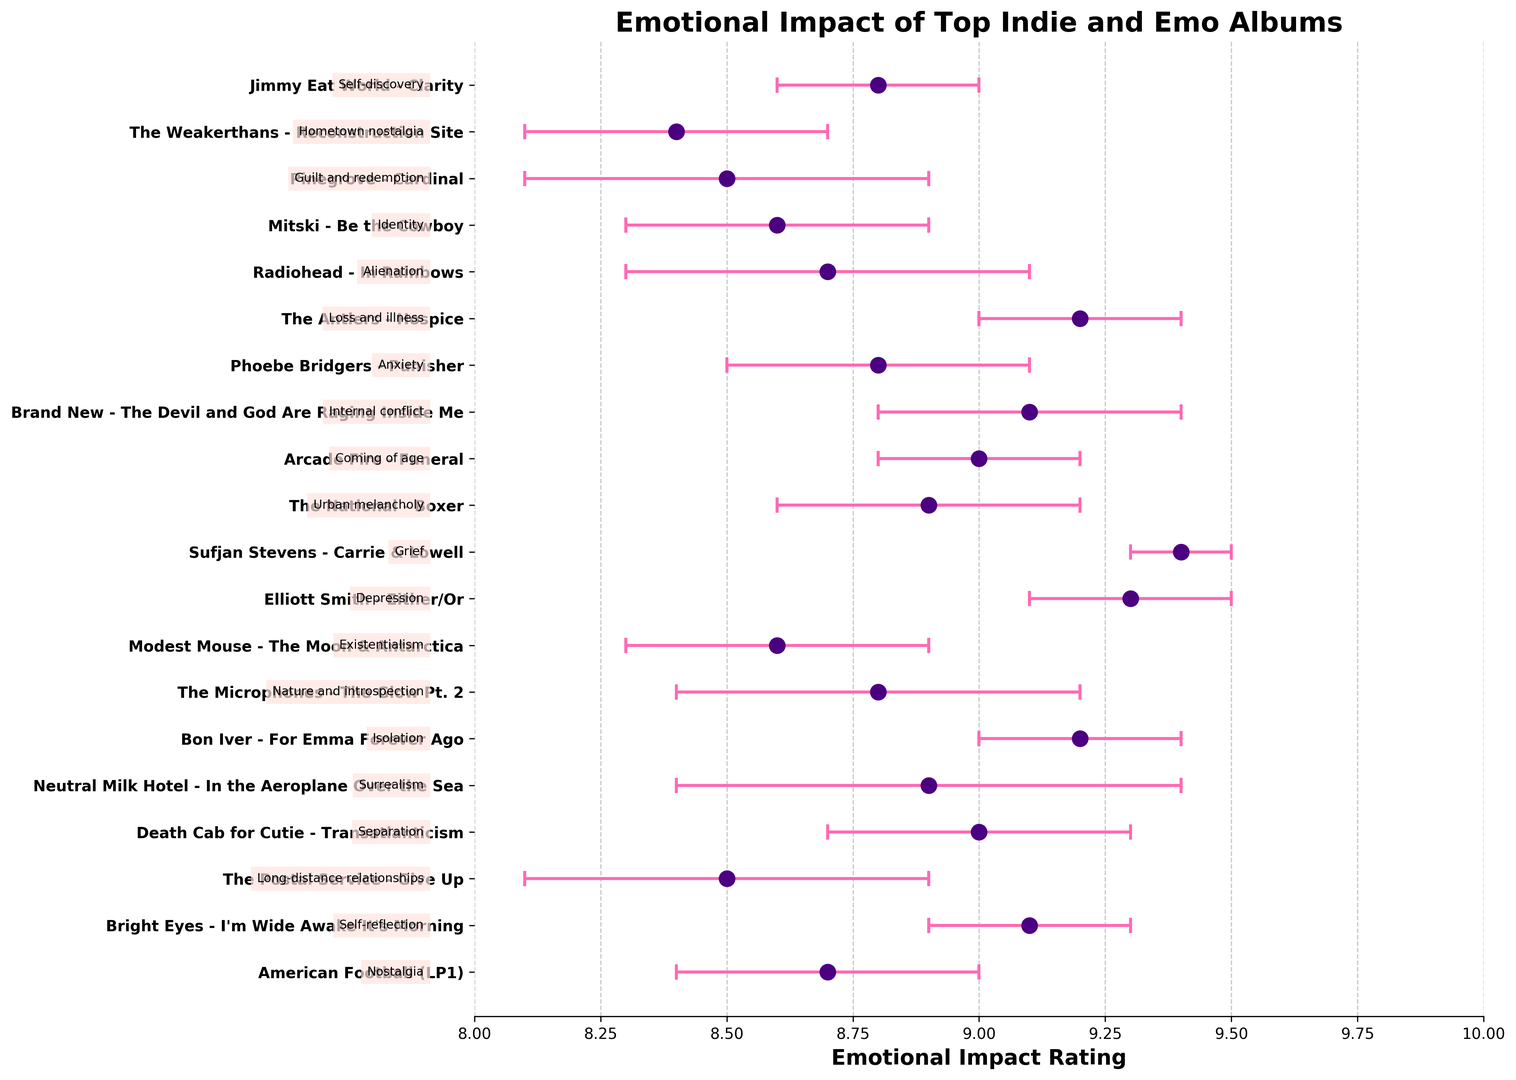What's the range of emotional impact ratings? The minimum rating is 8.4 (The Weakerthans - Reconstruction Site) and the maximum rating is 9.4 (Sufjan Stevens - Carrie & Lowell). The range is calculated as 9.4 - 8.4 = 1.
Answer: 1 Which album has the highest emotional impact rating? Sufjan Stevens - Carrie & Lowell has the highest emotional impact rating of 9.4.
Answer: Sufjan Stevens - Carrie & Lowell Which albums have an emotional impact rating of 8.7? The albums with an emotional impact rating of 8.7 are American Football (LP1) by American Football and In Rainbows by Radiohead, as indicated by the data points aligned at the 8.7 rating mark.
Answer: American Football (LP1) and In Rainbows How many albums have an emotional impact rating of 9.0 or higher? There are 8 albums with an emotional impact rating of 9.0 or higher: Bright Eyes - I'm Wide Awake It's Morning, Death Cab for Cutie - Transatlanticism, Neutral Milk Hotel - In the Aeroplane Over the Sea, Elliott Smith - Either/Or, Sufjan Stevens - Carrie & Lowell, Arcade Fire - Funeral, Brand New - The Devil and God Are Raging Inside Me, and The Antlers - Hospice.
Answer: 8 What is the average emotional impact rating of the albums with a rating lower than 9.0? The albums with ratings lower than 9.0 are: American Football (8.7), The Postal Service (8.5), Neutral Milk Hotel (8.9), The Microphones (8.8), Modest Mouse (8.6), The National (8.9), Phoebe Bridgers (8.8), Radiohead (8.7), Mitski (8.6), Pinegrove (8.5), The Weakerthans (8.4), and Jimmy Eat World (8.8). The average rating is calculated as (8.7 + 8.5 + 8.9 + 8.8 + 8.6 + 8.9 + 8.8 + 8.7 + 8.6 + 8.5 + 8.4 + 8.8) / 12 = 8.683 ≈ 8.7
Answer: 8.7 